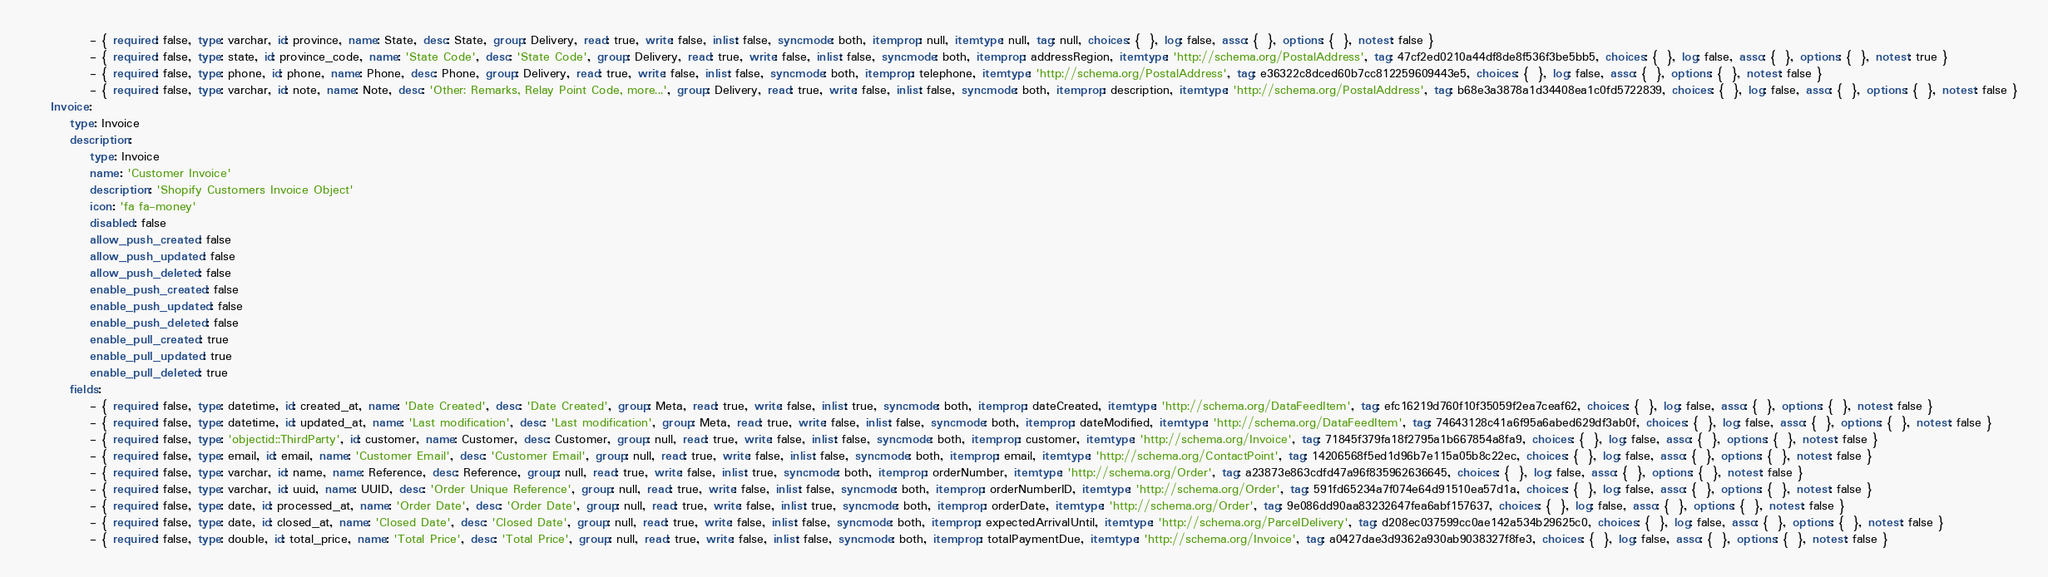<code> <loc_0><loc_0><loc_500><loc_500><_YAML_>            - { required: false, type: varchar, id: province, name: State, desc: State, group: Delivery, read: true, write: false, inlist: false, syncmode: both, itemprop: null, itemtype: null, tag: null, choices: {  }, log: false, asso: {  }, options: {  }, notest: false }
            - { required: false, type: state, id: province_code, name: 'State Code', desc: 'State Code', group: Delivery, read: true, write: false, inlist: false, syncmode: both, itemprop: addressRegion, itemtype: 'http://schema.org/PostalAddress', tag: 47cf2ed0210a44df8de8f536f3be5bb5, choices: {  }, log: false, asso: {  }, options: {  }, notest: true }
            - { required: false, type: phone, id: phone, name: Phone, desc: Phone, group: Delivery, read: true, write: false, inlist: false, syncmode: both, itemprop: telephone, itemtype: 'http://schema.org/PostalAddress', tag: e36322c8dced60b7cc812259609443e5, choices: {  }, log: false, asso: {  }, options: {  }, notest: false }
            - { required: false, type: varchar, id: note, name: Note, desc: 'Other: Remarks, Relay Point Code, more...', group: Delivery, read: true, write: false, inlist: false, syncmode: both, itemprop: description, itemtype: 'http://schema.org/PostalAddress', tag: b68e3a3878a1d34408ea1c0fd5722839, choices: {  }, log: false, asso: {  }, options: {  }, notest: false }
    Invoice:
        type: Invoice
        description:
            type: Invoice
            name: 'Customer Invoice'
            description: 'Shopify Customers Invoice Object'
            icon: 'fa fa-money'
            disabled: false
            allow_push_created: false
            allow_push_updated: false
            allow_push_deleted: false
            enable_push_created: false
            enable_push_updated: false
            enable_push_deleted: false
            enable_pull_created: true
            enable_pull_updated: true
            enable_pull_deleted: true
        fields:
            - { required: false, type: datetime, id: created_at, name: 'Date Created', desc: 'Date Created', group: Meta, read: true, write: false, inlist: true, syncmode: both, itemprop: dateCreated, itemtype: 'http://schema.org/DataFeedItem', tag: efc16219d760f10f35059f2ea7ceaf62, choices: {  }, log: false, asso: {  }, options: {  }, notest: false }
            - { required: false, type: datetime, id: updated_at, name: 'Last modification', desc: 'Last modification', group: Meta, read: true, write: false, inlist: false, syncmode: both, itemprop: dateModified, itemtype: 'http://schema.org/DataFeedItem', tag: 74643128c41a6f95a6abed629df3ab0f, choices: {  }, log: false, asso: {  }, options: {  }, notest: false }
            - { required: false, type: 'objectid::ThirdParty', id: customer, name: Customer, desc: Customer, group: null, read: true, write: false, inlist: false, syncmode: both, itemprop: customer, itemtype: 'http://schema.org/Invoice', tag: 71845f379fa18f2795a1b667854a8fa9, choices: {  }, log: false, asso: {  }, options: {  }, notest: false }
            - { required: false, type: email, id: email, name: 'Customer Email', desc: 'Customer Email', group: null, read: true, write: false, inlist: false, syncmode: both, itemprop: email, itemtype: 'http://schema.org/ContactPoint', tag: 14206568f5ed1d96b7e115a05b8c22ec, choices: {  }, log: false, asso: {  }, options: {  }, notest: false }
            - { required: false, type: varchar, id: name, name: Reference, desc: Reference, group: null, read: true, write: false, inlist: true, syncmode: both, itemprop: orderNumber, itemtype: 'http://schema.org/Order', tag: a23873e863cdfd47a96f835962636645, choices: {  }, log: false, asso: {  }, options: {  }, notest: false }
            - { required: false, type: varchar, id: uuid, name: UUID, desc: 'Order Unique Reference', group: null, read: true, write: false, inlist: false, syncmode: both, itemprop: orderNumberID, itemtype: 'http://schema.org/Order', tag: 591fd65234a7f074e64d91510ea57d1a, choices: {  }, log: false, asso: {  }, options: {  }, notest: false }
            - { required: false, type: date, id: processed_at, name: 'Order Date', desc: 'Order Date', group: null, read: true, write: false, inlist: true, syncmode: both, itemprop: orderDate, itemtype: 'http://schema.org/Order', tag: 9e086dd90aa83232647fea6abf157637, choices: {  }, log: false, asso: {  }, options: {  }, notest: false }
            - { required: false, type: date, id: closed_at, name: 'Closed Date', desc: 'Closed Date', group: null, read: true, write: false, inlist: false, syncmode: both, itemprop: expectedArrivalUntil, itemtype: 'http://schema.org/ParcelDelivery', tag: d208ec037599cc0ae142a534b29625c0, choices: {  }, log: false, asso: {  }, options: {  }, notest: false }
            - { required: false, type: double, id: total_price, name: 'Total Price', desc: 'Total Price', group: null, read: true, write: false, inlist: false, syncmode: both, itemprop: totalPaymentDue, itemtype: 'http://schema.org/Invoice', tag: a0427dae3d9362a930ab9038327f8fe3, choices: {  }, log: false, asso: {  }, options: {  }, notest: false }</code> 